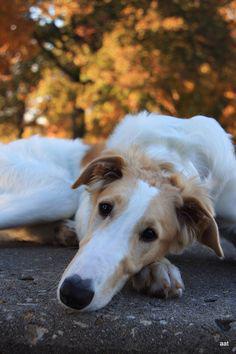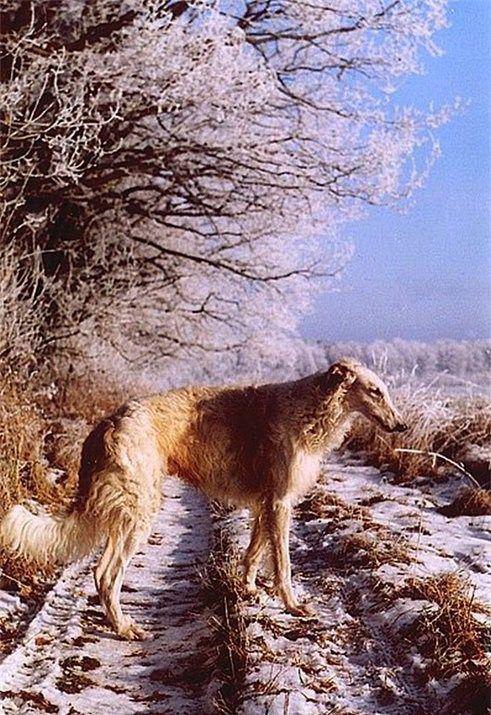The first image is the image on the left, the second image is the image on the right. For the images shown, is this caption "A woman is sitting with her two dogs." true? Answer yes or no. No. The first image is the image on the left, the second image is the image on the right. Given the left and right images, does the statement "A woman is sitting with her two dogs nearby." hold true? Answer yes or no. No. 